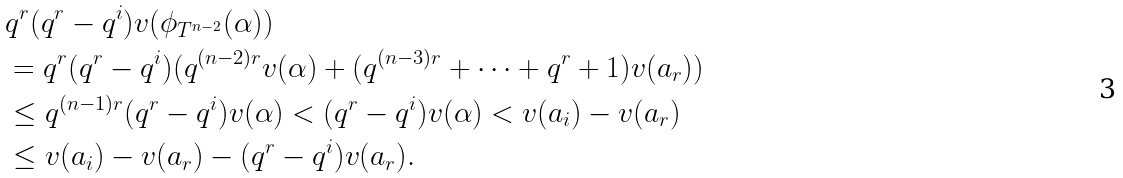<formula> <loc_0><loc_0><loc_500><loc_500>& q ^ { r } ( q ^ { r } - q ^ { i } ) v ( \phi _ { T ^ { n - 2 } } ( \alpha ) ) \\ & = q ^ { r } ( q ^ { r } - q ^ { i } ) ( q ^ { ( n - 2 ) r } v ( \alpha ) + ( q ^ { ( n - 3 ) r } + \dots + q ^ { r } + 1 ) v ( a _ { r } ) ) \\ & \leq q ^ { ( n - 1 ) r } ( q ^ { r } - q ^ { i } ) v ( \alpha ) < ( q ^ { r } - q ^ { i } ) v ( \alpha ) < v ( a _ { i } ) - v ( a _ { r } ) \\ & \leq v ( a _ { i } ) - v ( a _ { r } ) - ( q ^ { r } - q ^ { i } ) v ( a _ { r } ) .</formula> 